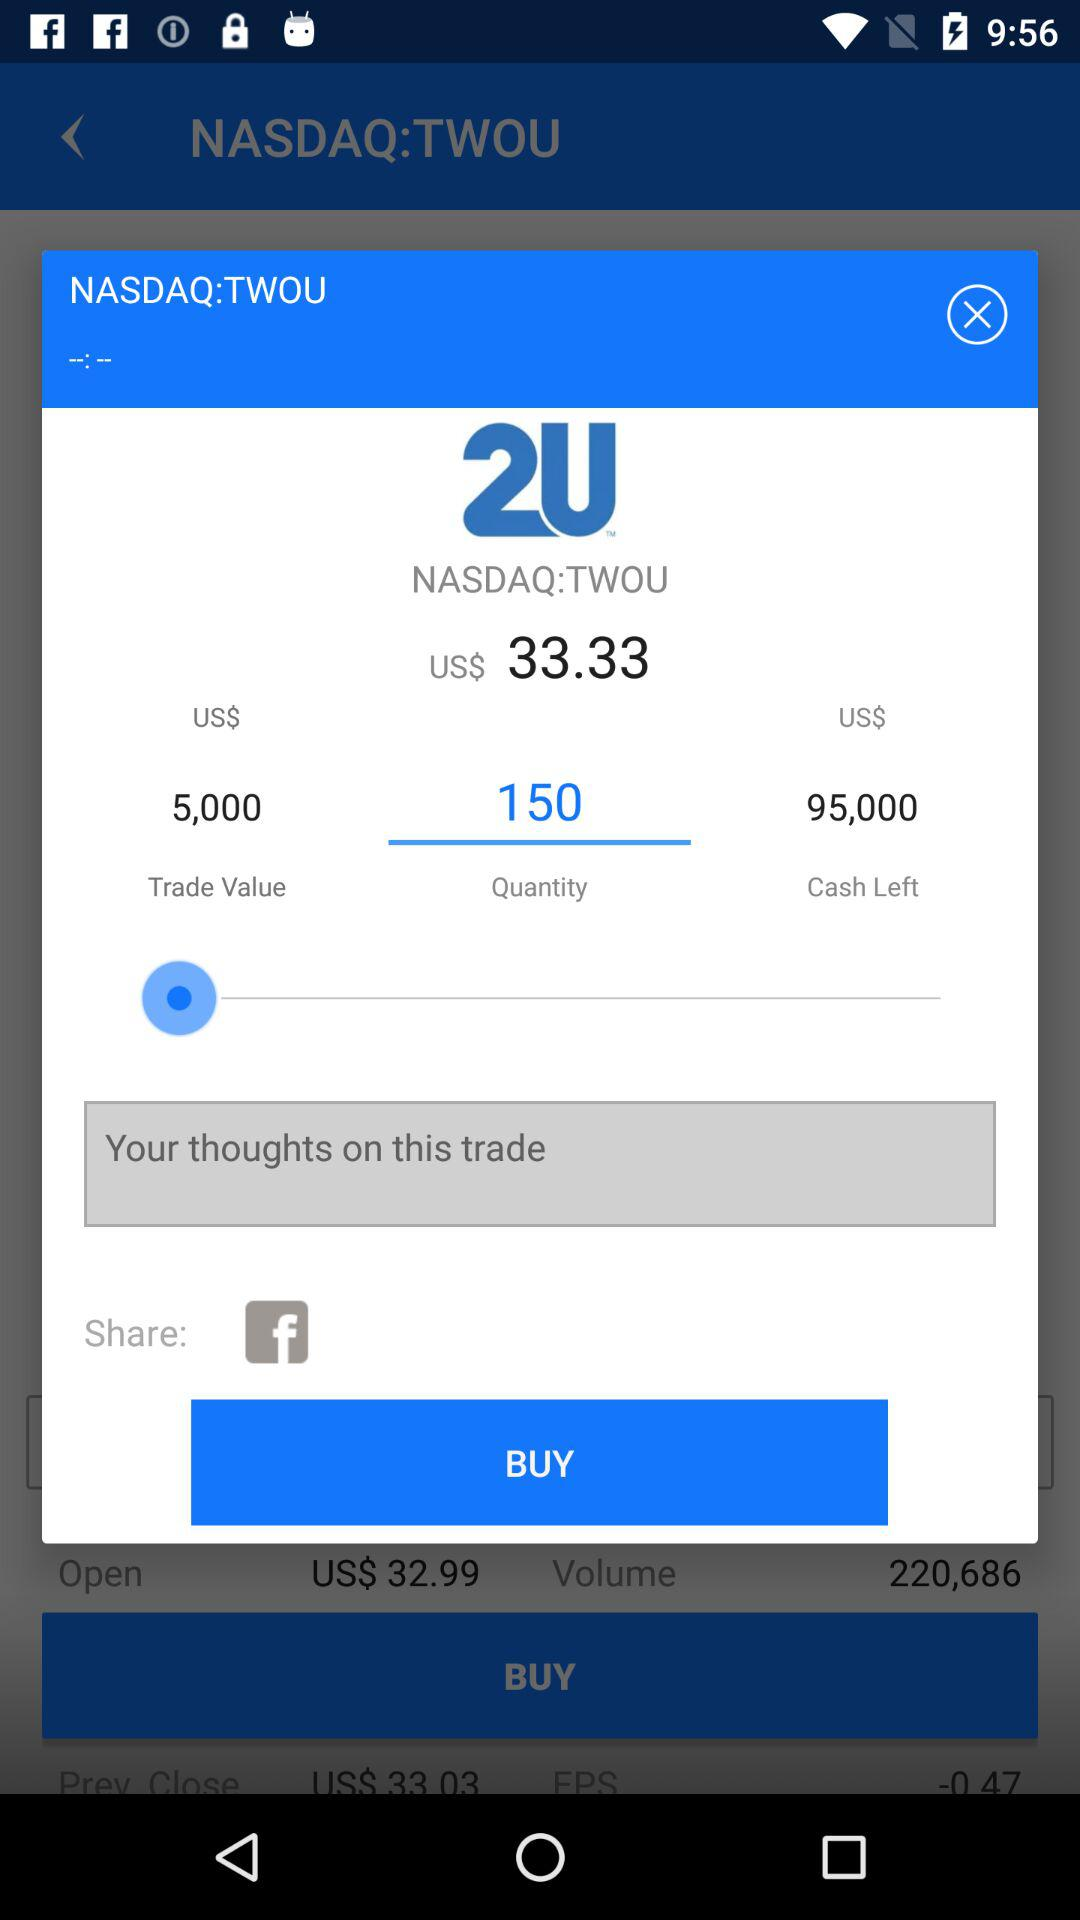What's the quantity? The quantity is 150. 